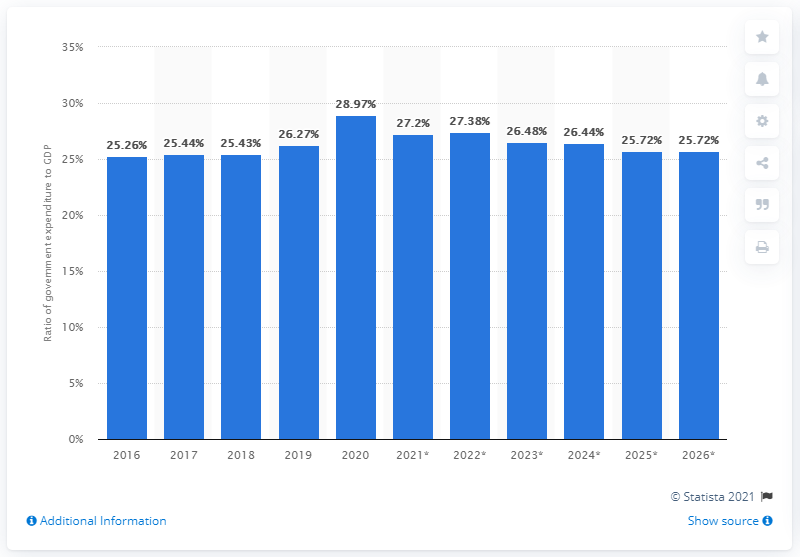Indicate a few pertinent items in this graphic. In 2020, government expenditure accounted for 28.97% of Chile's GDP. 